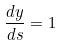Convert formula to latex. <formula><loc_0><loc_0><loc_500><loc_500>\frac { d y } { d s } = 1</formula> 